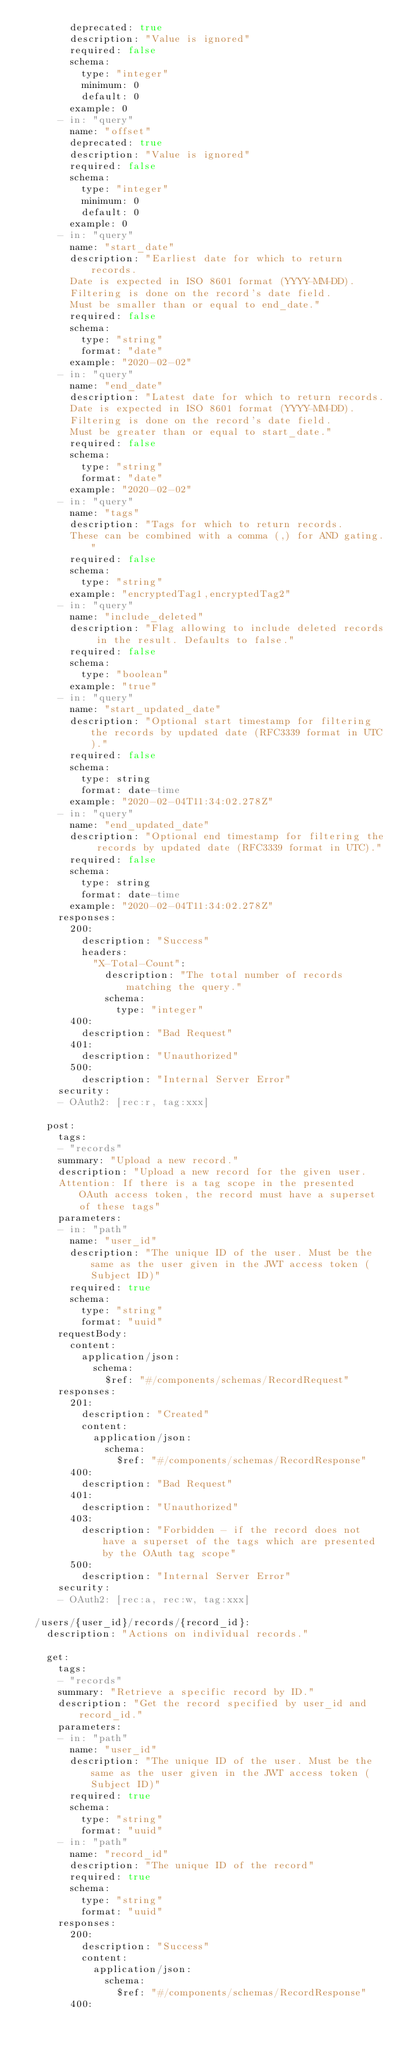Convert code to text. <code><loc_0><loc_0><loc_500><loc_500><_YAML_>        deprecated: true
        description: "Value is ignored"
        required: false
        schema:
          type: "integer"
          minimum: 0
          default: 0
        example: 0
      - in: "query"
        name: "offset"
        deprecated: true
        description: "Value is ignored"
        required: false
        schema:
          type: "integer"
          minimum: 0
          default: 0
        example: 0
      - in: "query"
        name: "start_date"
        description: "Earliest date for which to return records.
        Date is expected in ISO 8601 format (YYYY-MM-DD).
        Filtering is done on the record's date field.
        Must be smaller than or equal to end_date."
        required: false
        schema:
          type: "string"
          format: "date"
        example: "2020-02-02"
      - in: "query"
        name: "end_date"
        description: "Latest date for which to return records.
        Date is expected in ISO 8601 format (YYYY-MM-DD).
        Filtering is done on the record's date field.
        Must be greater than or equal to start_date."
        required: false
        schema:
          type: "string"
          format: "date"
        example: "2020-02-02"
      - in: "query"
        name: "tags"
        description: "Tags for which to return records.
        These can be combined with a comma (,) for AND gating."
        required: false
        schema:
          type: "string"
        example: "encryptedTag1,encryptedTag2"
      - in: "query"
        name: "include_deleted"
        description: "Flag allowing to include deleted records in the result. Defaults to false."
        required: false
        schema:
          type: "boolean"
        example: "true"
      - in: "query"
        name: "start_updated_date"
        description: "Optional start timestamp for filtering the records by updated date (RFC3339 format in UTC)."
        required: false
        schema:
          type: string
          format: date-time
        example: "2020-02-04T11:34:02.278Z"
      - in: "query"
        name: "end_updated_date"
        description: "Optional end timestamp for filtering the records by updated date (RFC3339 format in UTC)."
        required: false
        schema:
          type: string
          format: date-time
        example: "2020-02-04T11:34:02.278Z"
      responses:
        200:
          description: "Success"
          headers:
            "X-Total-Count":
              description: "The total number of records matching the query."
              schema:
                type: "integer"
        400:
          description: "Bad Request"
        401:
          description: "Unauthorized"
        500:
          description: "Internal Server Error"
      security:
      - OAuth2: [rec:r, tag:xxx]

    post:
      tags:
      - "records"
      summary: "Upload a new record."
      description: "Upload a new record for the given user.
      Attention: If there is a tag scope in the presented OAuth access token, the record must have a superset of these tags"
      parameters:
      - in: "path"
        name: "user_id"
        description: "The unique ID of the user. Must be the same as the user given in the JWT access token (Subject ID)"
        required: true
        schema:
          type: "string"
          format: "uuid"
      requestBody:
        content:
          application/json:
            schema:
              $ref: "#/components/schemas/RecordRequest"
      responses:
        201:
          description: "Created"
          content:
            application/json:
              schema:
                $ref: "#/components/schemas/RecordResponse"
        400:
          description: "Bad Request"
        401:
          description: "Unauthorized"
        403:
          description: "Forbidden - if the record does not have a superset of the tags which are presented by the OAuth tag scope"
        500:
          description: "Internal Server Error"
      security:
      - OAuth2: [rec:a, rec:w, tag:xxx]

  /users/{user_id}/records/{record_id}:
    description: "Actions on individual records."

    get:
      tags:
      - "records"
      summary: "Retrieve a specific record by ID."
      description: "Get the record specified by user_id and record_id."
      parameters:
      - in: "path"
        name: "user_id"
        description: "The unique ID of the user. Must be the same as the user given in the JWT access token (Subject ID)"
        required: true
        schema:
          type: "string"
          format: "uuid"
      - in: "path"
        name: "record_id"
        description: "The unique ID of the record"
        required: true
        schema:
          type: "string"
          format: "uuid"
      responses:
        200:
          description: "Success"
          content:
            application/json:
              schema:
                $ref: "#/components/schemas/RecordResponse"
        400:</code> 